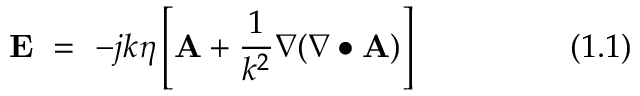Convert formula to latex. <formula><loc_0><loc_0><loc_500><loc_500>E = - j k \eta \left [ A + { \frac { 1 } { k ^ { 2 } } } \nabla ( \nabla \bullet A ) \right ] ( 1 . 1 )</formula> 